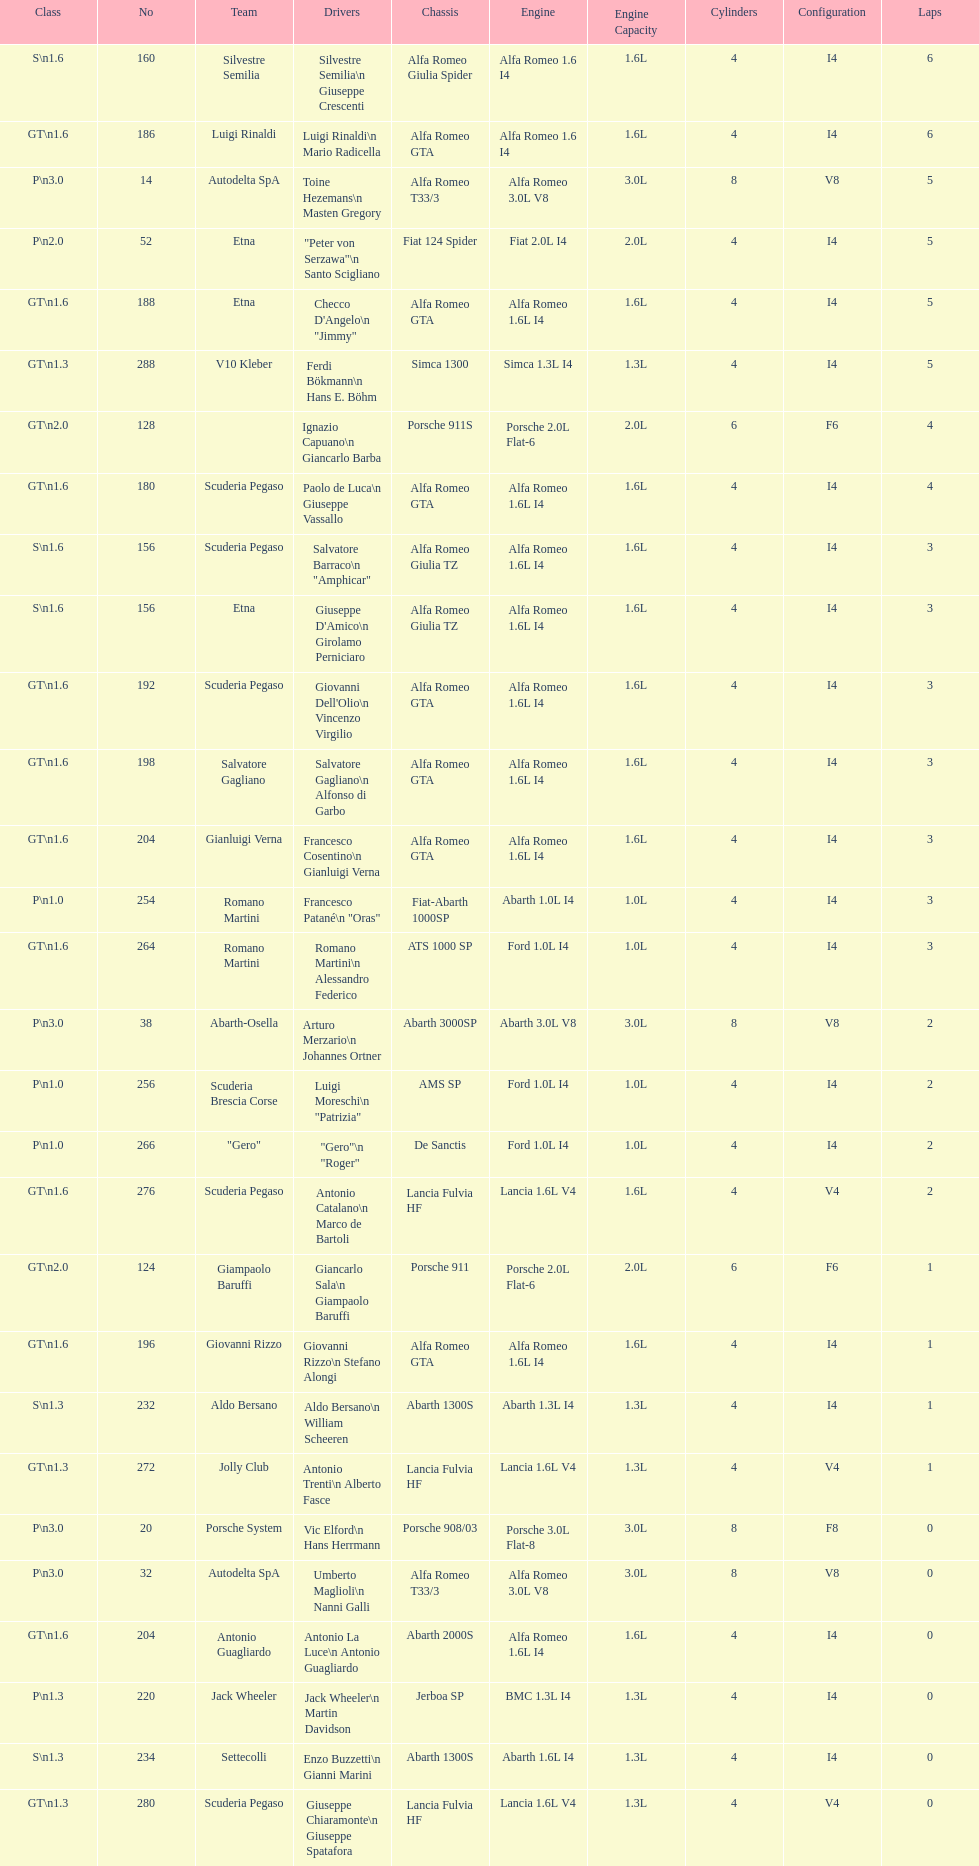How many drivers are from italy? 48. 